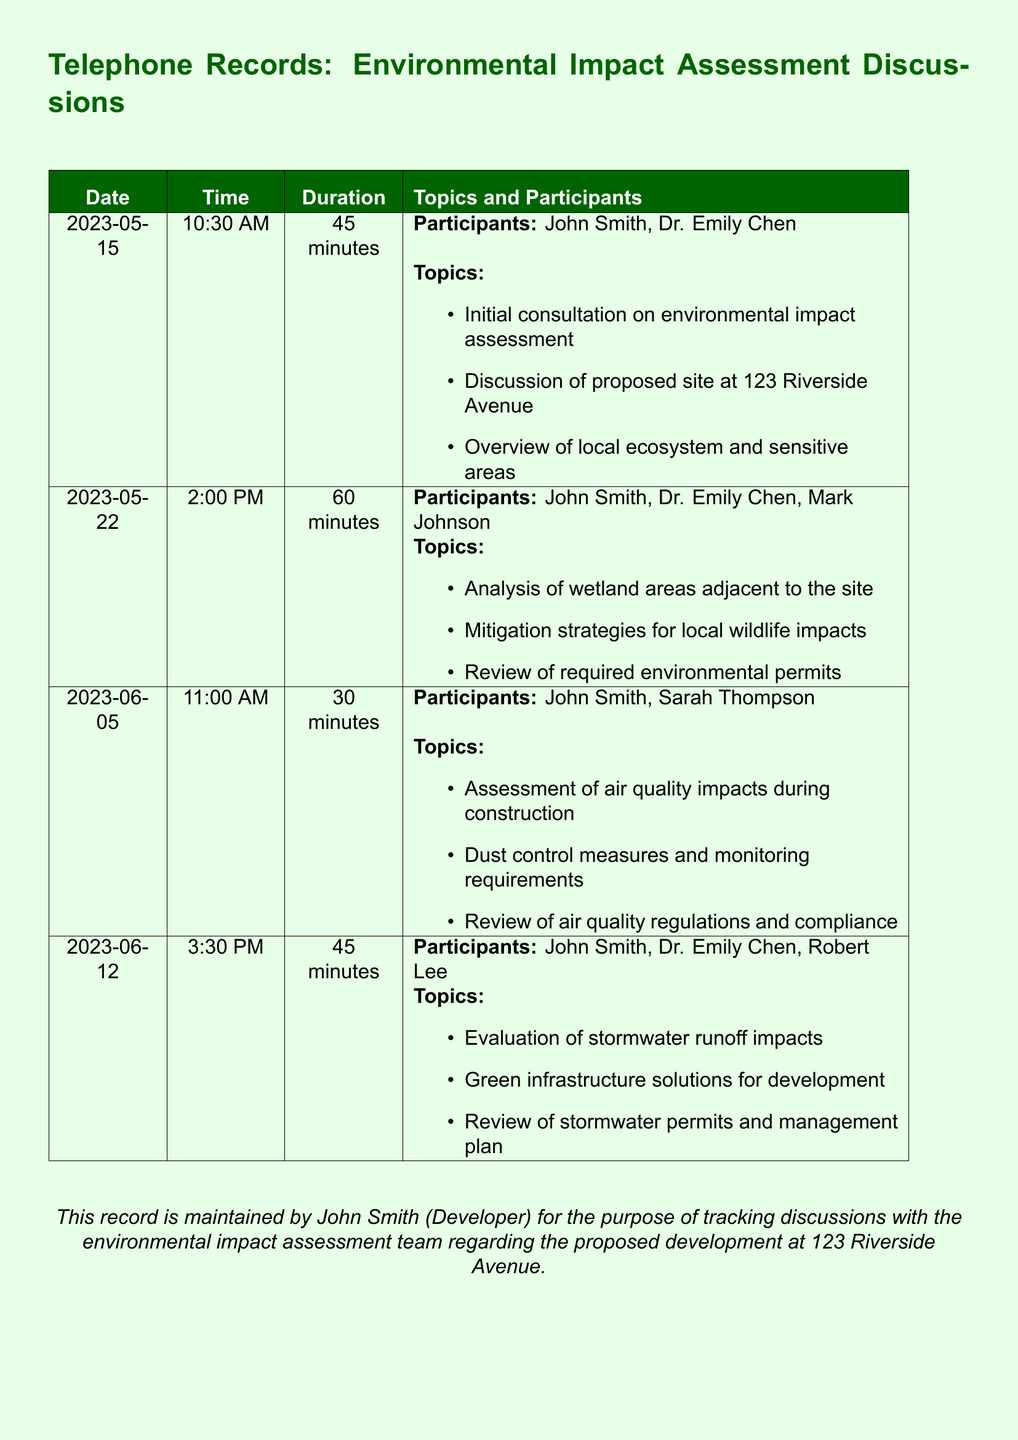What is the date of the first discussion? The date of the first discussion is found in the records, which lists the initial consultation date.
Answer: 2023-05-15 Who participated in the discussion on June 5th? The participants for the June 5th meeting are specified directly in the records.
Answer: John Smith, Sarah Thompson What was discussed on May 22nd? The records list the topics discussed during the May 22nd meeting about the site.
Answer: Analysis of wetland areas adjacent to the site How long did the June 12th discussion last? The duration of the June 12th discussion is shown in the document as part of the record details.
Answer: 45 minutes What is the proposed site address? The proposed site address is detailed clearly in the document under the discussions.
Answer: 123 Riverside Avenue Which participant is involved in all discussions? The records indicate which participants are present for each discussion session.
Answer: John Smith What was the focus of the discussion on June 5th? The topics of the June 5th discussion are outlined in the records for clarity.
Answer: Assessment of air quality impacts during construction How many discussions are recorded? The number of rows in the records corresponds to the total discussions documented.
Answer: Four 